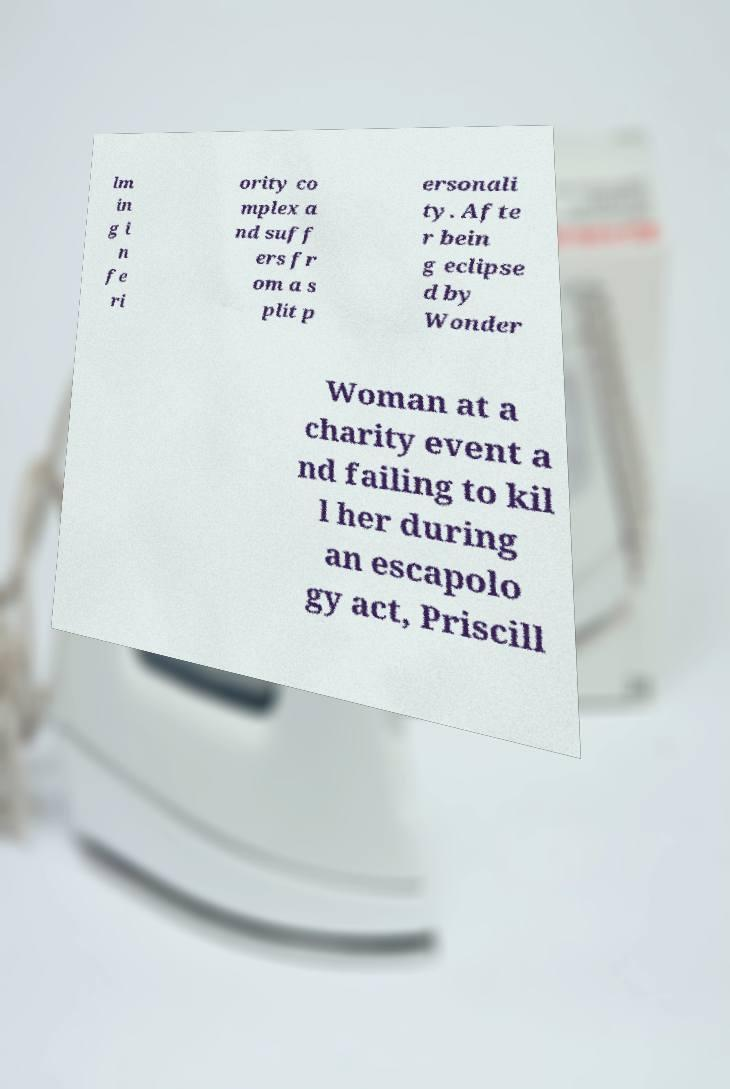I need the written content from this picture converted into text. Can you do that? lm in g i n fe ri ority co mplex a nd suff ers fr om a s plit p ersonali ty. Afte r bein g eclipse d by Wonder Woman at a charity event a nd failing to kil l her during an escapolo gy act, Priscill 